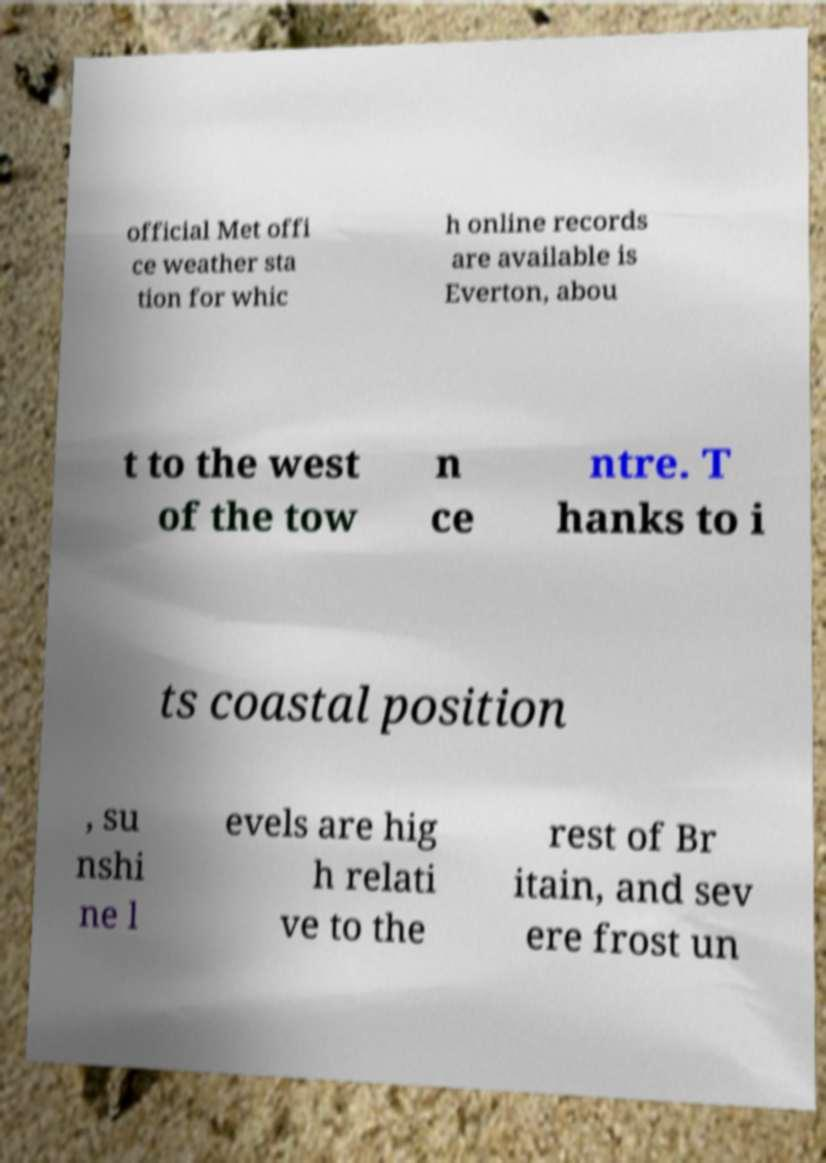Please identify and transcribe the text found in this image. official Met offi ce weather sta tion for whic h online records are available is Everton, abou t to the west of the tow n ce ntre. T hanks to i ts coastal position , su nshi ne l evels are hig h relati ve to the rest of Br itain, and sev ere frost un 